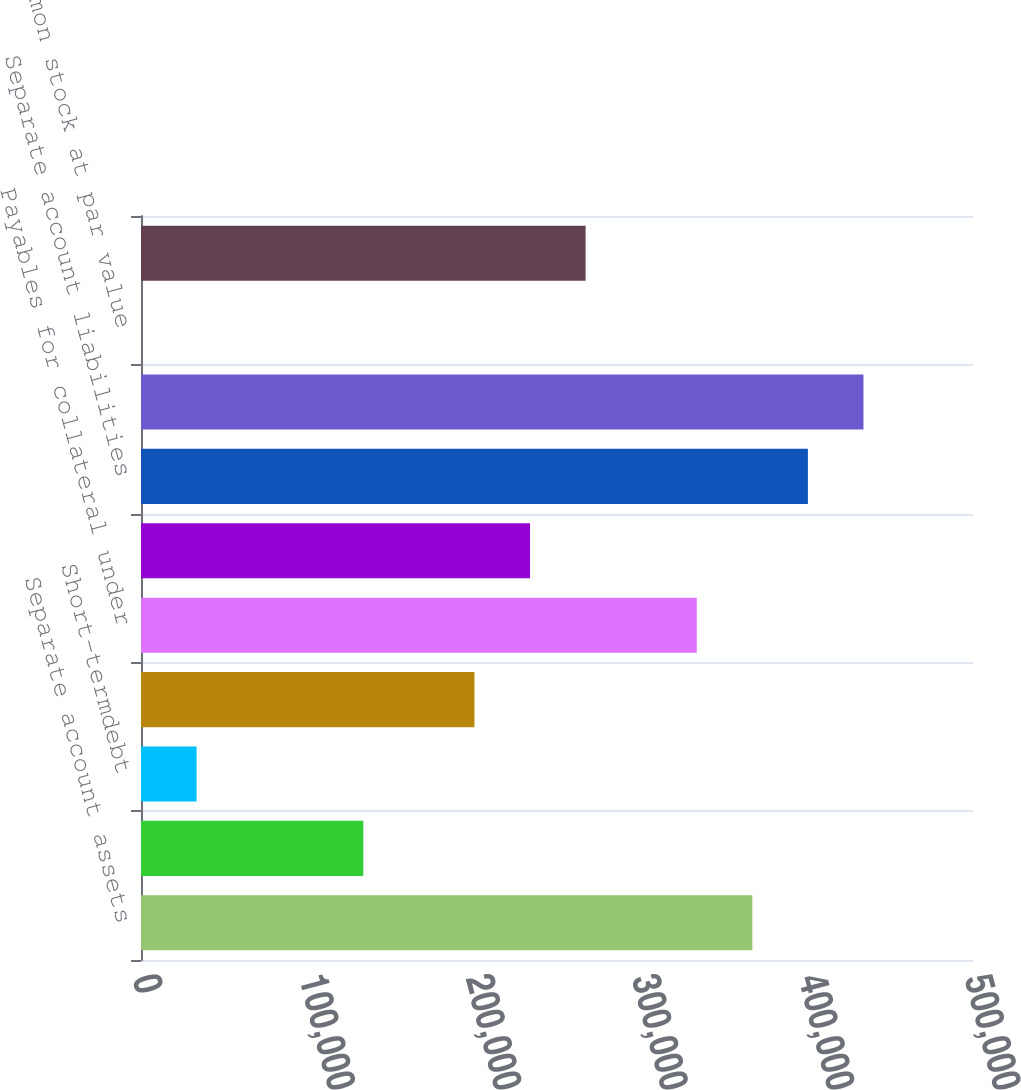Convert chart to OTSL. <chart><loc_0><loc_0><loc_500><loc_500><bar_chart><fcel>Separate account assets<fcel>Property and casualty<fcel>Short-termdebt<fcel>Long-termdebt<fcel>Payables for collateral under<fcel>Other<fcel>Separate account liabilities<fcel>Total liabilities(2)<fcel>Common stock at par value<fcel>Additional paid-in capital<nl><fcel>367382<fcel>133598<fcel>33405.6<fcel>200394<fcel>333984<fcel>233791<fcel>400779<fcel>434177<fcel>8<fcel>267189<nl></chart> 